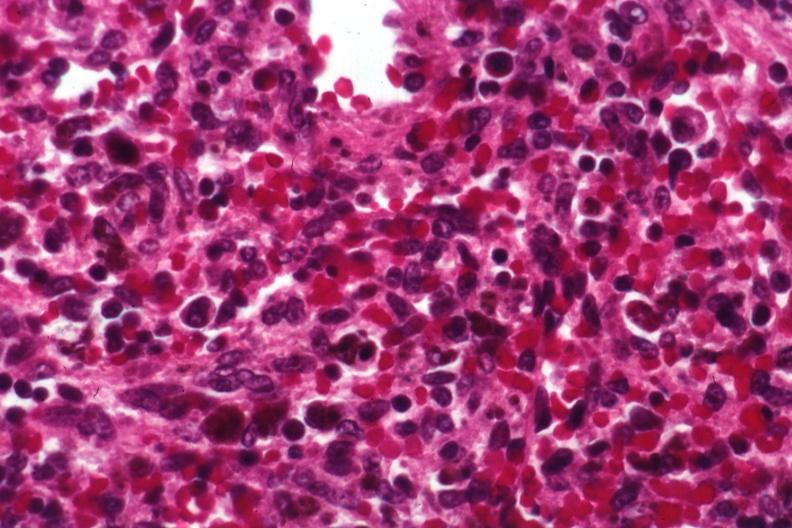s erythrophagocytosis new born present?
Answer the question using a single word or phrase. Yes 